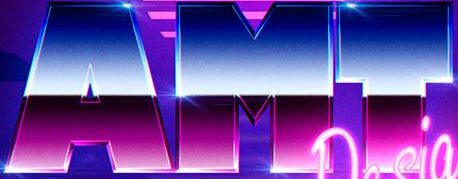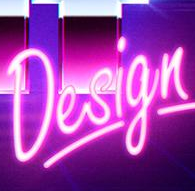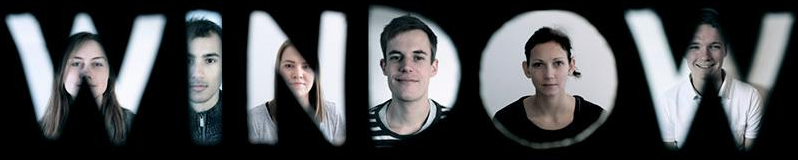What words are shown in these images in order, separated by a semicolon? AMT; Design; WINDOW 